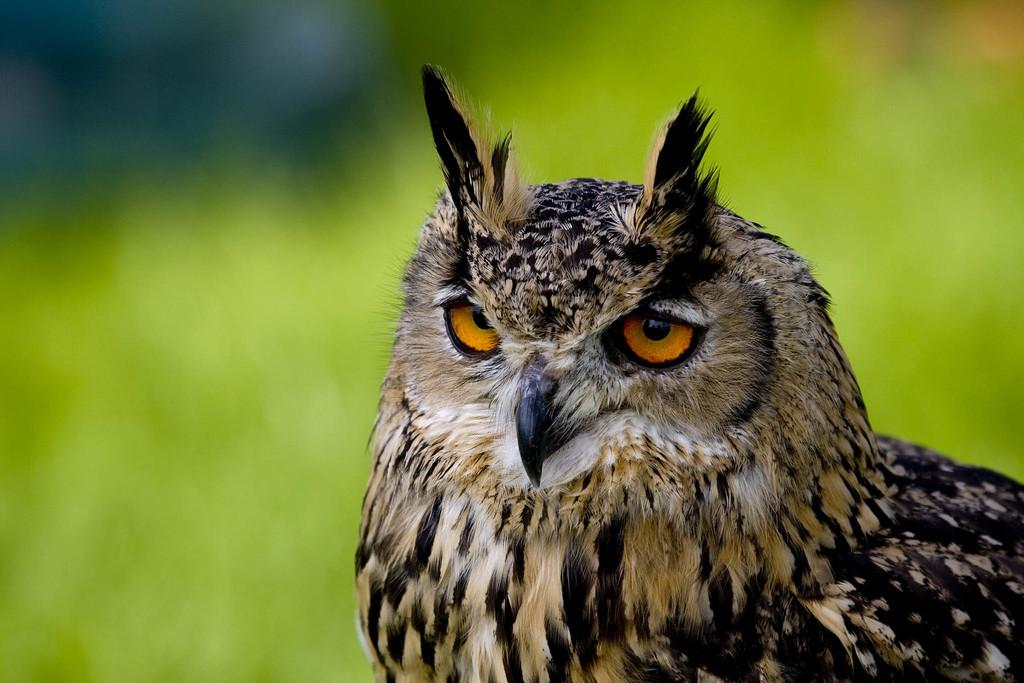What type of animal is in the image? There is an owl in the image. Can you describe the background of the image? The background of the image is blurred. What level of government is responsible for the owl's habitat in the image? There is no information about the owl's habitat or the level of government in the image. 